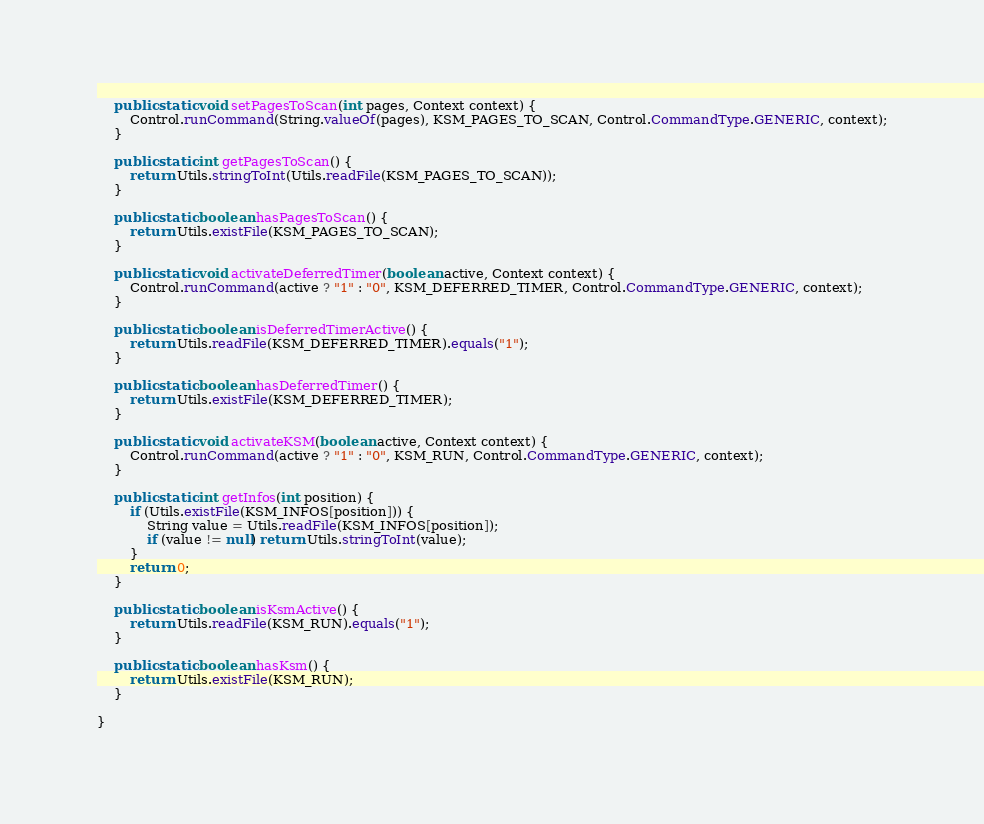Convert code to text. <code><loc_0><loc_0><loc_500><loc_500><_Java_>
    public static void setPagesToScan(int pages, Context context) {
        Control.runCommand(String.valueOf(pages), KSM_PAGES_TO_SCAN, Control.CommandType.GENERIC, context);
    }

    public static int getPagesToScan() {
        return Utils.stringToInt(Utils.readFile(KSM_PAGES_TO_SCAN));
    }

    public static boolean hasPagesToScan() {
        return Utils.existFile(KSM_PAGES_TO_SCAN);
    }

    public static void activateDeferredTimer(boolean active, Context context) {
        Control.runCommand(active ? "1" : "0", KSM_DEFERRED_TIMER, Control.CommandType.GENERIC, context);
    }

    public static boolean isDeferredTimerActive() {
        return Utils.readFile(KSM_DEFERRED_TIMER).equals("1");
    }

    public static boolean hasDeferredTimer() {
        return Utils.existFile(KSM_DEFERRED_TIMER);
    }

    public static void activateKSM(boolean active, Context context) {
        Control.runCommand(active ? "1" : "0", KSM_RUN, Control.CommandType.GENERIC, context);
    }

    public static int getInfos(int position) {
        if (Utils.existFile(KSM_INFOS[position])) {
            String value = Utils.readFile(KSM_INFOS[position]);
            if (value != null) return Utils.stringToInt(value);
        }
        return 0;
    }

    public static boolean isKsmActive() {
        return Utils.readFile(KSM_RUN).equals("1");
    }

    public static boolean hasKsm() {
        return Utils.existFile(KSM_RUN);
    }

}
</code> 